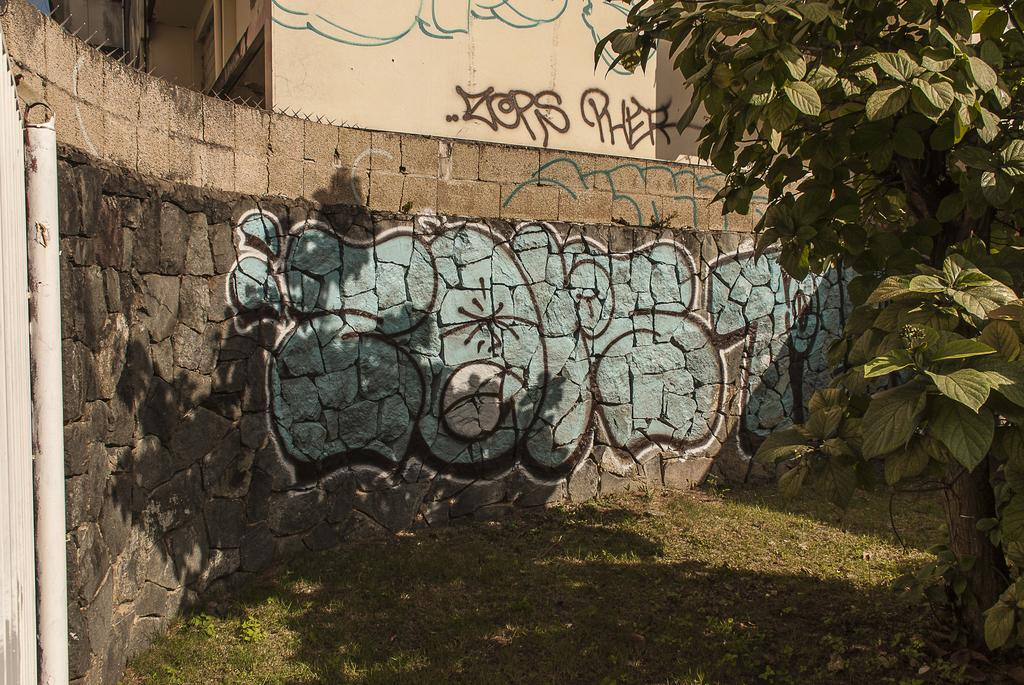What type of vegetation is present on the ground in the image? There is grass on the ground in the image. What other natural elements can be seen in the image? There are trees visible in the image. What is in the background of the image? There is a wall in the background of the image. Can you describe the wall in the background? There is a painting on the wall in the background. What type of neck accessory is being worn by the tree in the image? There are no neck accessories present in the image, as it features grass, trees, a wall, and a painting. 